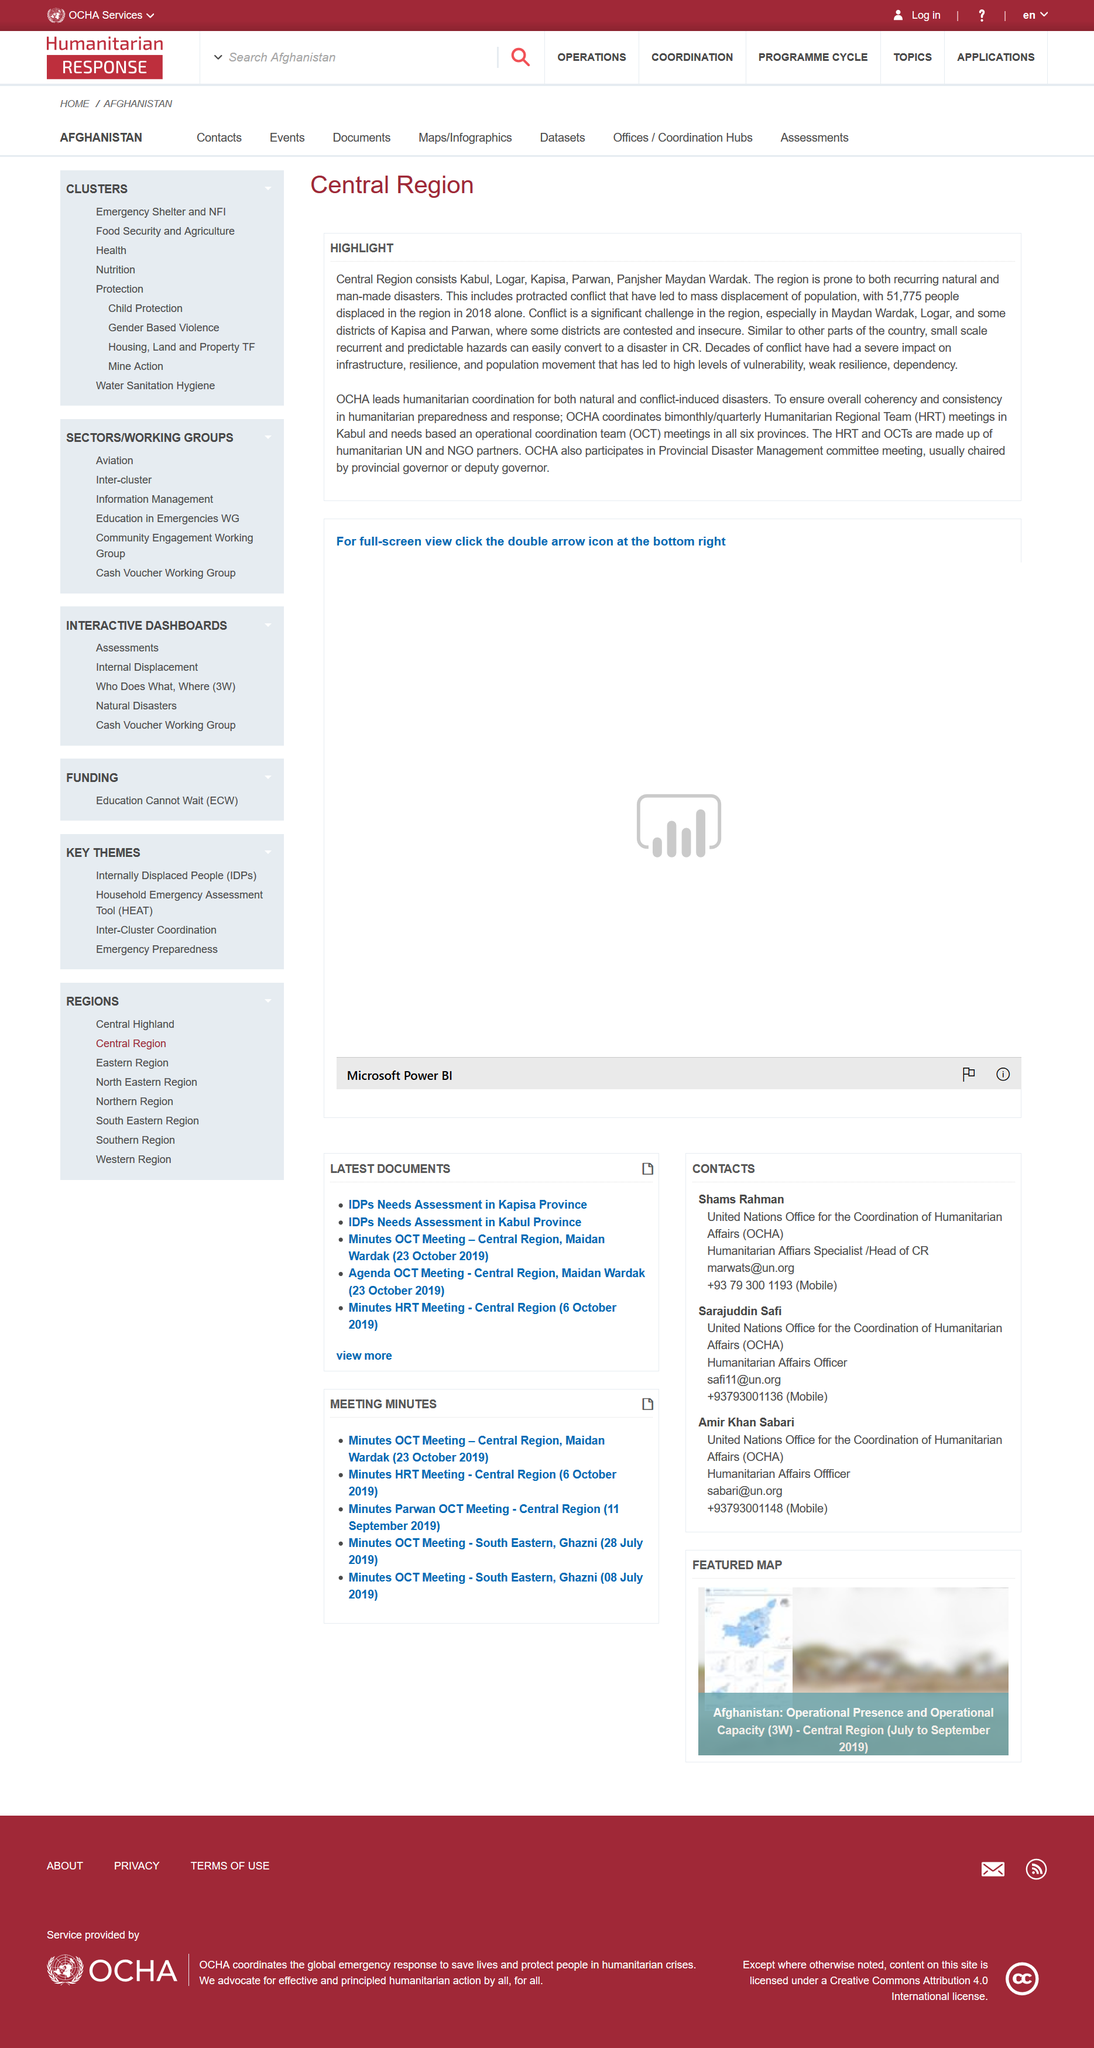List a handful of essential elements in this visual. In 2018, a total of 51,775 individuals were displaced in the Central Region. The Office for the Coordination of Humanitarian Affairs (OCHA) leads humanitarian coordination for natural and conflict-induced disasters in the Central Region. The Central Region comprises of Kabul, Logar, Kapisa, Parwan, and Panjsher Maydan Wardak, which are the provinces that make up this region. 